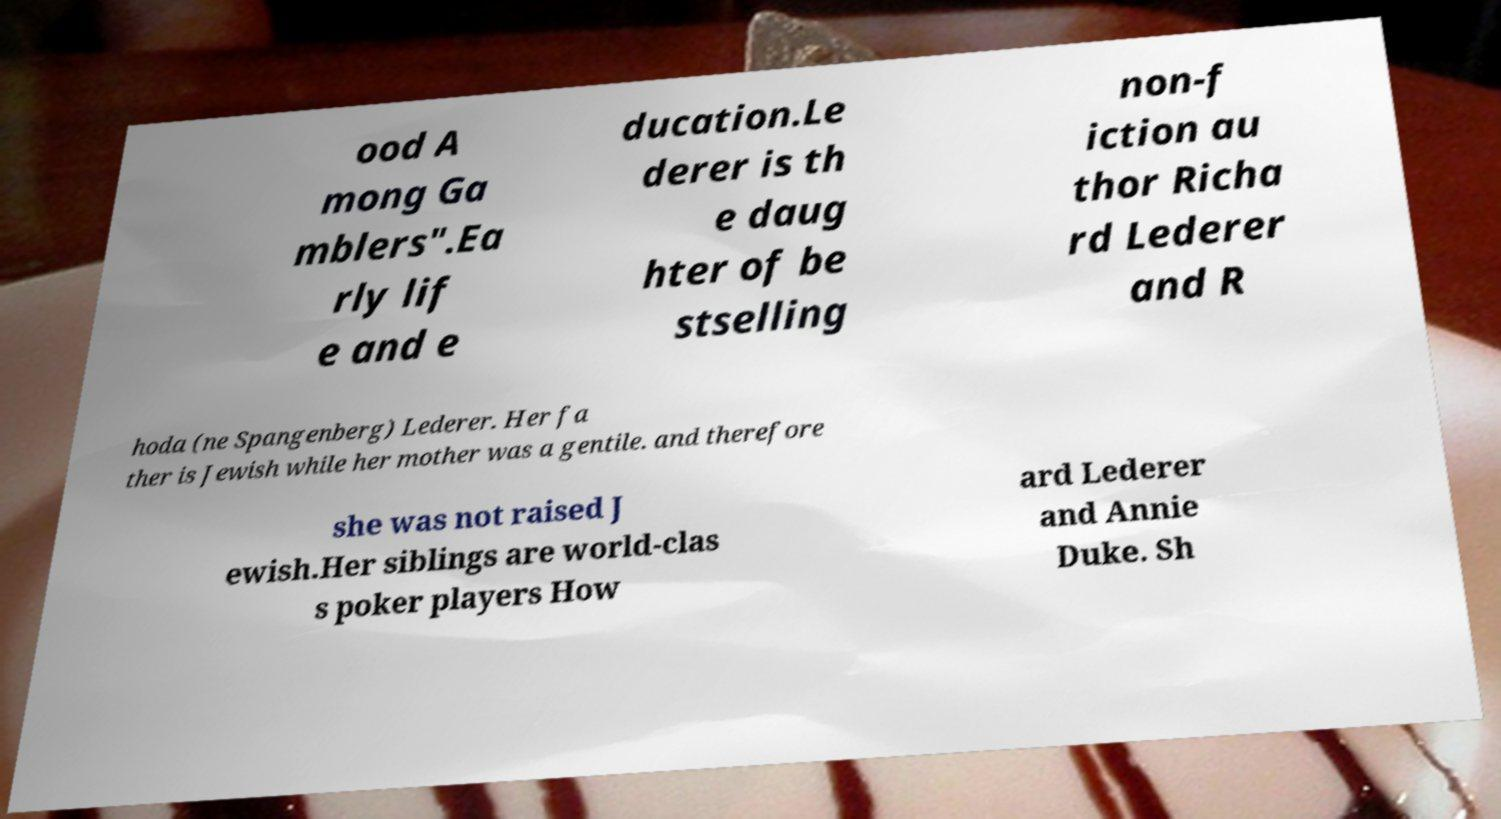Can you read and provide the text displayed in the image?This photo seems to have some interesting text. Can you extract and type it out for me? ood A mong Ga mblers".Ea rly lif e and e ducation.Le derer is th e daug hter of be stselling non-f iction au thor Richa rd Lederer and R hoda (ne Spangenberg) Lederer. Her fa ther is Jewish while her mother was a gentile. and therefore she was not raised J ewish.Her siblings are world-clas s poker players How ard Lederer and Annie Duke. Sh 